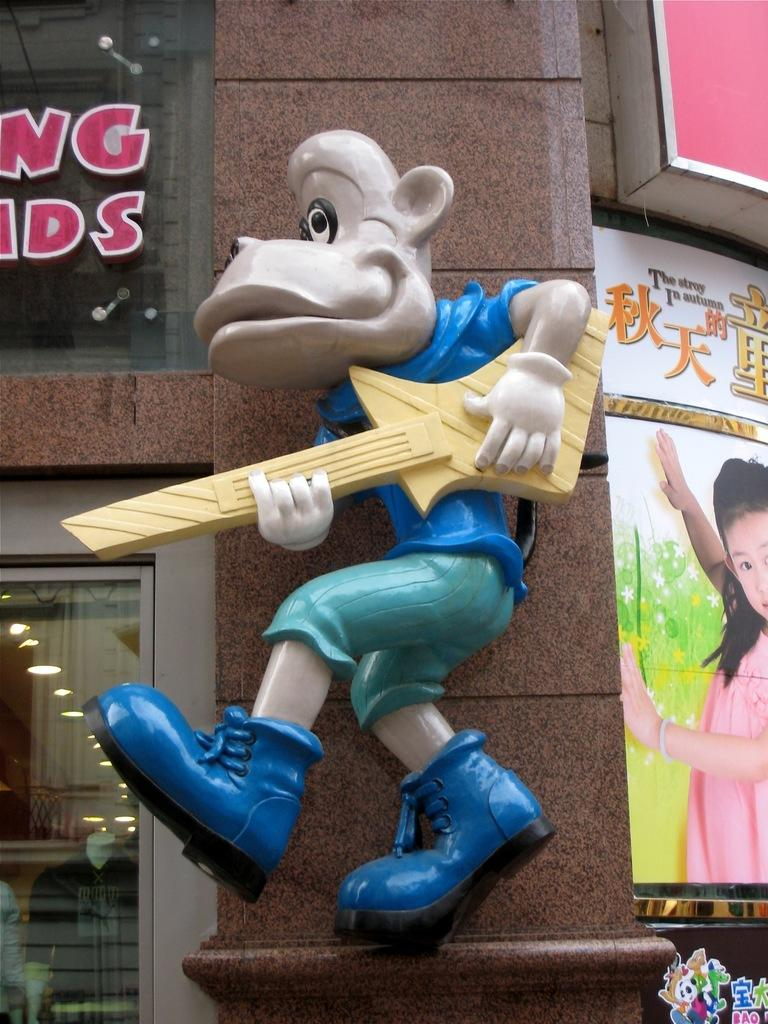What is placed on the building's pillar in the image? There is a doll structure on a building's pillar. What can be seen on either side of the doll structure? There are posters on either side of the doll structure. What type of surface do the name boards appear to be on? The name boards are on glass windows. How many geese are visible in the image? There are no geese present in the image. What type of jeans is the doll wearing in the image? The image does not show the doll wearing any jeans, as it is a doll structure and not a living person. 